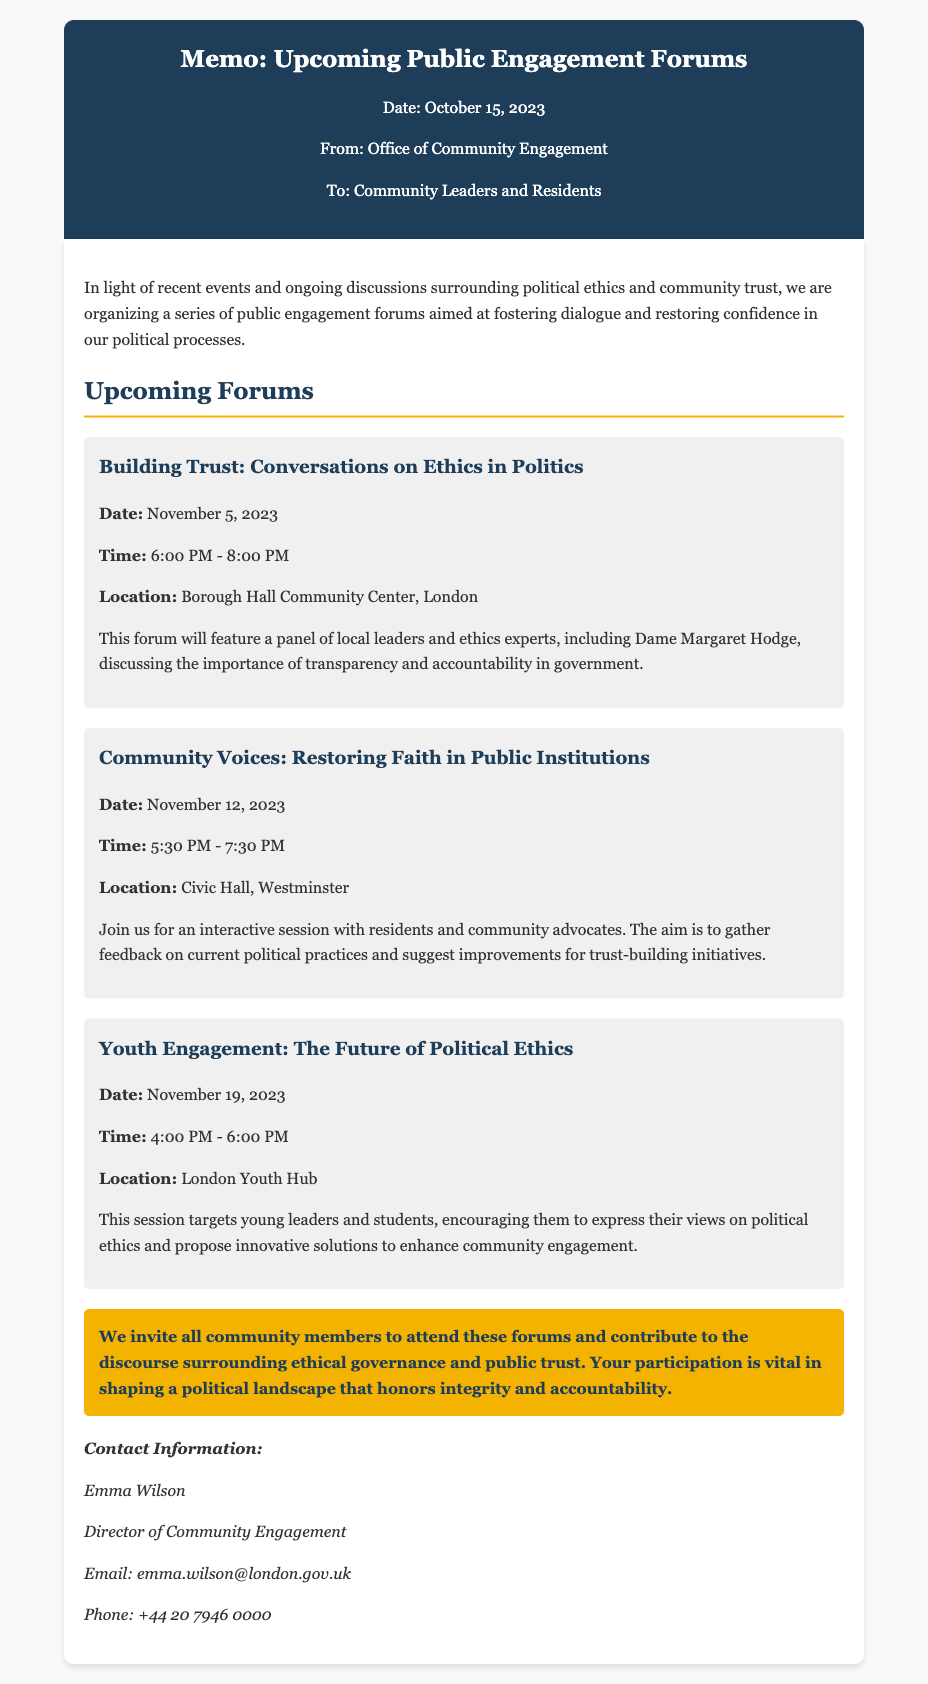What is the date of the first forum? The date of the first forum is specified in the memo as November 5, 2023.
Answer: November 5, 2023 Who will be speaking at the first forum? The memo mentions that the first forum will feature a panel including Dame Margaret Hodge.
Answer: Dame Margaret Hodge What is the time duration of the second forum? The second forum is scheduled to run from 5:30 PM to 7:30 PM, which is a duration of 2 hours.
Answer: 2 hours Where is the third forum being held? The location for the third forum, according to the memo, is the London Youth Hub.
Answer: London Youth Hub What is the main purpose of the forums? The memo states that the forums aim to foster dialogue and restore confidence in political processes.
Answer: Restore confidence in political processes How many forums are listed in the memo? The memo details a total of three upcoming forums focused on different aspects of political ethics and community trust.
Answer: Three forums What is the contact person's email address? The contact information in the memo provides the email address of Emma Wilson as emma.wilson@london.gov.uk.
Answer: emma.wilson@london.gov.uk What is the title of the second forum? The title of the second forum is specifically mentioned as "Community Voices: Restoring Faith in Public Institutions."
Answer: Community Voices: Restoring Faith in Public Institutions What type of engagement is targeted in the third forum? The third forum targets young leaders and students for engagement on political ethics.
Answer: Young leaders and students 